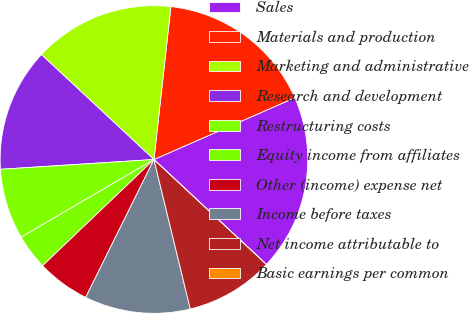<chart> <loc_0><loc_0><loc_500><loc_500><pie_chart><fcel>Sales<fcel>Materials and production<fcel>Marketing and administrative<fcel>Research and development<fcel>Restructuring costs<fcel>Equity income from affiliates<fcel>Other (income) expense net<fcel>Income before taxes<fcel>Net income attributable to<fcel>Basic earnings per common<nl><fcel>18.52%<fcel>16.67%<fcel>14.81%<fcel>12.96%<fcel>7.41%<fcel>3.7%<fcel>5.56%<fcel>11.11%<fcel>9.26%<fcel>0.0%<nl></chart> 